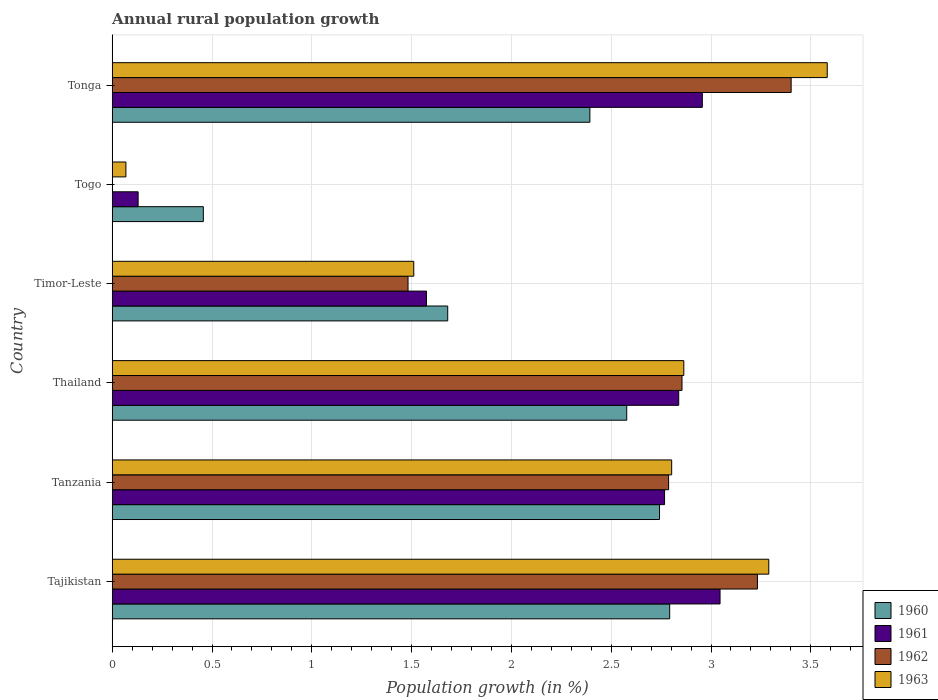How many bars are there on the 1st tick from the top?
Offer a terse response. 4. What is the label of the 5th group of bars from the top?
Offer a very short reply. Tanzania. In how many cases, is the number of bars for a given country not equal to the number of legend labels?
Keep it short and to the point. 1. What is the percentage of rural population growth in 1962 in Thailand?
Your answer should be compact. 2.85. Across all countries, what is the maximum percentage of rural population growth in 1963?
Ensure brevity in your answer.  3.58. Across all countries, what is the minimum percentage of rural population growth in 1962?
Ensure brevity in your answer.  0. In which country was the percentage of rural population growth in 1963 maximum?
Your response must be concise. Tonga. What is the total percentage of rural population growth in 1960 in the graph?
Ensure brevity in your answer.  12.64. What is the difference between the percentage of rural population growth in 1963 in Timor-Leste and that in Tonga?
Keep it short and to the point. -2.07. What is the difference between the percentage of rural population growth in 1960 in Timor-Leste and the percentage of rural population growth in 1962 in Thailand?
Your response must be concise. -1.17. What is the average percentage of rural population growth in 1960 per country?
Provide a succinct answer. 2.11. What is the difference between the percentage of rural population growth in 1962 and percentage of rural population growth in 1961 in Tonga?
Your answer should be very brief. 0.44. In how many countries, is the percentage of rural population growth in 1960 greater than 2.2 %?
Your answer should be compact. 4. What is the ratio of the percentage of rural population growth in 1963 in Tanzania to that in Togo?
Offer a very short reply. 40.89. Is the percentage of rural population growth in 1960 in Tajikistan less than that in Timor-Leste?
Your response must be concise. No. What is the difference between the highest and the second highest percentage of rural population growth in 1961?
Make the answer very short. 0.09. What is the difference between the highest and the lowest percentage of rural population growth in 1960?
Keep it short and to the point. 2.34. Is the sum of the percentage of rural population growth in 1960 in Timor-Leste and Tonga greater than the maximum percentage of rural population growth in 1961 across all countries?
Provide a succinct answer. Yes. Is it the case that in every country, the sum of the percentage of rural population growth in 1962 and percentage of rural population growth in 1960 is greater than the sum of percentage of rural population growth in 1961 and percentage of rural population growth in 1963?
Provide a succinct answer. No. Is it the case that in every country, the sum of the percentage of rural population growth in 1962 and percentage of rural population growth in 1961 is greater than the percentage of rural population growth in 1963?
Give a very brief answer. Yes. How many bars are there?
Give a very brief answer. 23. Are all the bars in the graph horizontal?
Provide a succinct answer. Yes. How many countries are there in the graph?
Your answer should be very brief. 6. Are the values on the major ticks of X-axis written in scientific E-notation?
Keep it short and to the point. No. Does the graph contain grids?
Keep it short and to the point. Yes. Where does the legend appear in the graph?
Offer a terse response. Bottom right. How are the legend labels stacked?
Your answer should be compact. Vertical. What is the title of the graph?
Make the answer very short. Annual rural population growth. Does "1979" appear as one of the legend labels in the graph?
Ensure brevity in your answer.  No. What is the label or title of the X-axis?
Your response must be concise. Population growth (in %). What is the label or title of the Y-axis?
Offer a very short reply. Country. What is the Population growth (in %) in 1960 in Tajikistan?
Offer a very short reply. 2.79. What is the Population growth (in %) of 1961 in Tajikistan?
Give a very brief answer. 3.05. What is the Population growth (in %) of 1962 in Tajikistan?
Your answer should be very brief. 3.23. What is the Population growth (in %) of 1963 in Tajikistan?
Ensure brevity in your answer.  3.29. What is the Population growth (in %) in 1960 in Tanzania?
Provide a short and direct response. 2.74. What is the Population growth (in %) in 1961 in Tanzania?
Give a very brief answer. 2.77. What is the Population growth (in %) in 1962 in Tanzania?
Offer a terse response. 2.79. What is the Population growth (in %) in 1963 in Tanzania?
Offer a very short reply. 2.8. What is the Population growth (in %) in 1960 in Thailand?
Your answer should be very brief. 2.58. What is the Population growth (in %) of 1961 in Thailand?
Offer a terse response. 2.84. What is the Population growth (in %) of 1962 in Thailand?
Your answer should be very brief. 2.85. What is the Population growth (in %) of 1963 in Thailand?
Give a very brief answer. 2.86. What is the Population growth (in %) in 1960 in Timor-Leste?
Provide a succinct answer. 1.68. What is the Population growth (in %) in 1961 in Timor-Leste?
Ensure brevity in your answer.  1.57. What is the Population growth (in %) of 1962 in Timor-Leste?
Provide a short and direct response. 1.48. What is the Population growth (in %) of 1963 in Timor-Leste?
Offer a very short reply. 1.51. What is the Population growth (in %) of 1960 in Togo?
Provide a short and direct response. 0.46. What is the Population growth (in %) of 1961 in Togo?
Your response must be concise. 0.13. What is the Population growth (in %) in 1962 in Togo?
Your answer should be very brief. 0. What is the Population growth (in %) in 1963 in Togo?
Give a very brief answer. 0.07. What is the Population growth (in %) of 1960 in Tonga?
Keep it short and to the point. 2.39. What is the Population growth (in %) in 1961 in Tonga?
Your answer should be very brief. 2.96. What is the Population growth (in %) of 1962 in Tonga?
Your answer should be compact. 3.4. What is the Population growth (in %) of 1963 in Tonga?
Provide a succinct answer. 3.58. Across all countries, what is the maximum Population growth (in %) in 1960?
Provide a succinct answer. 2.79. Across all countries, what is the maximum Population growth (in %) of 1961?
Make the answer very short. 3.05. Across all countries, what is the maximum Population growth (in %) in 1962?
Offer a terse response. 3.4. Across all countries, what is the maximum Population growth (in %) of 1963?
Make the answer very short. 3.58. Across all countries, what is the minimum Population growth (in %) of 1960?
Make the answer very short. 0.46. Across all countries, what is the minimum Population growth (in %) of 1961?
Make the answer very short. 0.13. Across all countries, what is the minimum Population growth (in %) of 1963?
Give a very brief answer. 0.07. What is the total Population growth (in %) of 1960 in the graph?
Make the answer very short. 12.64. What is the total Population growth (in %) in 1961 in the graph?
Offer a very short reply. 13.31. What is the total Population growth (in %) of 1962 in the graph?
Offer a terse response. 13.76. What is the total Population growth (in %) of 1963 in the graph?
Your answer should be compact. 14.12. What is the difference between the Population growth (in %) of 1960 in Tajikistan and that in Tanzania?
Your answer should be very brief. 0.05. What is the difference between the Population growth (in %) of 1961 in Tajikistan and that in Tanzania?
Your answer should be very brief. 0.28. What is the difference between the Population growth (in %) of 1962 in Tajikistan and that in Tanzania?
Offer a very short reply. 0.45. What is the difference between the Population growth (in %) of 1963 in Tajikistan and that in Tanzania?
Give a very brief answer. 0.49. What is the difference between the Population growth (in %) of 1960 in Tajikistan and that in Thailand?
Offer a terse response. 0.22. What is the difference between the Population growth (in %) in 1961 in Tajikistan and that in Thailand?
Your answer should be very brief. 0.21. What is the difference between the Population growth (in %) of 1962 in Tajikistan and that in Thailand?
Your response must be concise. 0.38. What is the difference between the Population growth (in %) of 1963 in Tajikistan and that in Thailand?
Ensure brevity in your answer.  0.43. What is the difference between the Population growth (in %) in 1960 in Tajikistan and that in Timor-Leste?
Make the answer very short. 1.11. What is the difference between the Population growth (in %) of 1961 in Tajikistan and that in Timor-Leste?
Offer a terse response. 1.47. What is the difference between the Population growth (in %) of 1962 in Tajikistan and that in Timor-Leste?
Your answer should be very brief. 1.75. What is the difference between the Population growth (in %) in 1963 in Tajikistan and that in Timor-Leste?
Offer a very short reply. 1.78. What is the difference between the Population growth (in %) in 1960 in Tajikistan and that in Togo?
Keep it short and to the point. 2.34. What is the difference between the Population growth (in %) of 1961 in Tajikistan and that in Togo?
Provide a succinct answer. 2.92. What is the difference between the Population growth (in %) of 1963 in Tajikistan and that in Togo?
Ensure brevity in your answer.  3.22. What is the difference between the Population growth (in %) in 1960 in Tajikistan and that in Tonga?
Make the answer very short. 0.4. What is the difference between the Population growth (in %) of 1961 in Tajikistan and that in Tonga?
Provide a short and direct response. 0.09. What is the difference between the Population growth (in %) of 1962 in Tajikistan and that in Tonga?
Your response must be concise. -0.17. What is the difference between the Population growth (in %) in 1963 in Tajikistan and that in Tonga?
Offer a terse response. -0.29. What is the difference between the Population growth (in %) of 1960 in Tanzania and that in Thailand?
Your answer should be very brief. 0.16. What is the difference between the Population growth (in %) of 1961 in Tanzania and that in Thailand?
Make the answer very short. -0.07. What is the difference between the Population growth (in %) of 1962 in Tanzania and that in Thailand?
Your answer should be very brief. -0.07. What is the difference between the Population growth (in %) of 1963 in Tanzania and that in Thailand?
Your answer should be very brief. -0.06. What is the difference between the Population growth (in %) of 1960 in Tanzania and that in Timor-Leste?
Ensure brevity in your answer.  1.06. What is the difference between the Population growth (in %) of 1961 in Tanzania and that in Timor-Leste?
Provide a short and direct response. 1.19. What is the difference between the Population growth (in %) of 1962 in Tanzania and that in Timor-Leste?
Your answer should be very brief. 1.31. What is the difference between the Population growth (in %) of 1963 in Tanzania and that in Timor-Leste?
Offer a very short reply. 1.29. What is the difference between the Population growth (in %) of 1960 in Tanzania and that in Togo?
Make the answer very short. 2.29. What is the difference between the Population growth (in %) of 1961 in Tanzania and that in Togo?
Offer a terse response. 2.64. What is the difference between the Population growth (in %) in 1963 in Tanzania and that in Togo?
Offer a terse response. 2.73. What is the difference between the Population growth (in %) of 1960 in Tanzania and that in Tonga?
Your response must be concise. 0.35. What is the difference between the Population growth (in %) of 1961 in Tanzania and that in Tonga?
Provide a succinct answer. -0.19. What is the difference between the Population growth (in %) in 1962 in Tanzania and that in Tonga?
Your response must be concise. -0.61. What is the difference between the Population growth (in %) in 1963 in Tanzania and that in Tonga?
Your response must be concise. -0.78. What is the difference between the Population growth (in %) in 1960 in Thailand and that in Timor-Leste?
Provide a succinct answer. 0.9. What is the difference between the Population growth (in %) of 1961 in Thailand and that in Timor-Leste?
Ensure brevity in your answer.  1.26. What is the difference between the Population growth (in %) in 1962 in Thailand and that in Timor-Leste?
Make the answer very short. 1.37. What is the difference between the Population growth (in %) of 1963 in Thailand and that in Timor-Leste?
Ensure brevity in your answer.  1.35. What is the difference between the Population growth (in %) in 1960 in Thailand and that in Togo?
Make the answer very short. 2.12. What is the difference between the Population growth (in %) in 1961 in Thailand and that in Togo?
Give a very brief answer. 2.71. What is the difference between the Population growth (in %) of 1963 in Thailand and that in Togo?
Provide a short and direct response. 2.8. What is the difference between the Population growth (in %) of 1960 in Thailand and that in Tonga?
Make the answer very short. 0.18. What is the difference between the Population growth (in %) in 1961 in Thailand and that in Tonga?
Provide a succinct answer. -0.12. What is the difference between the Population growth (in %) in 1962 in Thailand and that in Tonga?
Make the answer very short. -0.55. What is the difference between the Population growth (in %) of 1963 in Thailand and that in Tonga?
Give a very brief answer. -0.72. What is the difference between the Population growth (in %) of 1960 in Timor-Leste and that in Togo?
Provide a succinct answer. 1.22. What is the difference between the Population growth (in %) in 1961 in Timor-Leste and that in Togo?
Your answer should be very brief. 1.44. What is the difference between the Population growth (in %) in 1963 in Timor-Leste and that in Togo?
Ensure brevity in your answer.  1.44. What is the difference between the Population growth (in %) in 1960 in Timor-Leste and that in Tonga?
Keep it short and to the point. -0.71. What is the difference between the Population growth (in %) of 1961 in Timor-Leste and that in Tonga?
Your response must be concise. -1.38. What is the difference between the Population growth (in %) in 1962 in Timor-Leste and that in Tonga?
Offer a terse response. -1.92. What is the difference between the Population growth (in %) of 1963 in Timor-Leste and that in Tonga?
Make the answer very short. -2.07. What is the difference between the Population growth (in %) in 1960 in Togo and that in Tonga?
Give a very brief answer. -1.94. What is the difference between the Population growth (in %) in 1961 in Togo and that in Tonga?
Your answer should be very brief. -2.83. What is the difference between the Population growth (in %) of 1963 in Togo and that in Tonga?
Your answer should be very brief. -3.51. What is the difference between the Population growth (in %) in 1960 in Tajikistan and the Population growth (in %) in 1961 in Tanzania?
Keep it short and to the point. 0.03. What is the difference between the Population growth (in %) in 1960 in Tajikistan and the Population growth (in %) in 1962 in Tanzania?
Your response must be concise. 0.01. What is the difference between the Population growth (in %) in 1960 in Tajikistan and the Population growth (in %) in 1963 in Tanzania?
Give a very brief answer. -0.01. What is the difference between the Population growth (in %) of 1961 in Tajikistan and the Population growth (in %) of 1962 in Tanzania?
Give a very brief answer. 0.26. What is the difference between the Population growth (in %) of 1961 in Tajikistan and the Population growth (in %) of 1963 in Tanzania?
Give a very brief answer. 0.24. What is the difference between the Population growth (in %) in 1962 in Tajikistan and the Population growth (in %) in 1963 in Tanzania?
Provide a succinct answer. 0.43. What is the difference between the Population growth (in %) in 1960 in Tajikistan and the Population growth (in %) in 1961 in Thailand?
Provide a succinct answer. -0.05. What is the difference between the Population growth (in %) of 1960 in Tajikistan and the Population growth (in %) of 1962 in Thailand?
Offer a terse response. -0.06. What is the difference between the Population growth (in %) of 1960 in Tajikistan and the Population growth (in %) of 1963 in Thailand?
Your answer should be very brief. -0.07. What is the difference between the Population growth (in %) of 1961 in Tajikistan and the Population growth (in %) of 1962 in Thailand?
Offer a very short reply. 0.19. What is the difference between the Population growth (in %) of 1961 in Tajikistan and the Population growth (in %) of 1963 in Thailand?
Give a very brief answer. 0.18. What is the difference between the Population growth (in %) of 1962 in Tajikistan and the Population growth (in %) of 1963 in Thailand?
Your answer should be very brief. 0.37. What is the difference between the Population growth (in %) in 1960 in Tajikistan and the Population growth (in %) in 1961 in Timor-Leste?
Your answer should be compact. 1.22. What is the difference between the Population growth (in %) of 1960 in Tajikistan and the Population growth (in %) of 1962 in Timor-Leste?
Offer a very short reply. 1.31. What is the difference between the Population growth (in %) in 1960 in Tajikistan and the Population growth (in %) in 1963 in Timor-Leste?
Give a very brief answer. 1.28. What is the difference between the Population growth (in %) of 1961 in Tajikistan and the Population growth (in %) of 1962 in Timor-Leste?
Offer a terse response. 1.56. What is the difference between the Population growth (in %) of 1961 in Tajikistan and the Population growth (in %) of 1963 in Timor-Leste?
Ensure brevity in your answer.  1.53. What is the difference between the Population growth (in %) in 1962 in Tajikistan and the Population growth (in %) in 1963 in Timor-Leste?
Provide a short and direct response. 1.72. What is the difference between the Population growth (in %) in 1960 in Tajikistan and the Population growth (in %) in 1961 in Togo?
Your response must be concise. 2.66. What is the difference between the Population growth (in %) in 1960 in Tajikistan and the Population growth (in %) in 1963 in Togo?
Give a very brief answer. 2.72. What is the difference between the Population growth (in %) in 1961 in Tajikistan and the Population growth (in %) in 1963 in Togo?
Your answer should be compact. 2.98. What is the difference between the Population growth (in %) in 1962 in Tajikistan and the Population growth (in %) in 1963 in Togo?
Your answer should be very brief. 3.16. What is the difference between the Population growth (in %) in 1960 in Tajikistan and the Population growth (in %) in 1961 in Tonga?
Provide a succinct answer. -0.16. What is the difference between the Population growth (in %) of 1960 in Tajikistan and the Population growth (in %) of 1962 in Tonga?
Offer a very short reply. -0.61. What is the difference between the Population growth (in %) of 1960 in Tajikistan and the Population growth (in %) of 1963 in Tonga?
Ensure brevity in your answer.  -0.79. What is the difference between the Population growth (in %) of 1961 in Tajikistan and the Population growth (in %) of 1962 in Tonga?
Provide a short and direct response. -0.36. What is the difference between the Population growth (in %) of 1961 in Tajikistan and the Population growth (in %) of 1963 in Tonga?
Keep it short and to the point. -0.54. What is the difference between the Population growth (in %) of 1962 in Tajikistan and the Population growth (in %) of 1963 in Tonga?
Provide a succinct answer. -0.35. What is the difference between the Population growth (in %) in 1960 in Tanzania and the Population growth (in %) in 1961 in Thailand?
Offer a terse response. -0.1. What is the difference between the Population growth (in %) of 1960 in Tanzania and the Population growth (in %) of 1962 in Thailand?
Give a very brief answer. -0.11. What is the difference between the Population growth (in %) of 1960 in Tanzania and the Population growth (in %) of 1963 in Thailand?
Offer a very short reply. -0.12. What is the difference between the Population growth (in %) in 1961 in Tanzania and the Population growth (in %) in 1962 in Thailand?
Keep it short and to the point. -0.09. What is the difference between the Population growth (in %) in 1961 in Tanzania and the Population growth (in %) in 1963 in Thailand?
Your answer should be very brief. -0.1. What is the difference between the Population growth (in %) of 1962 in Tanzania and the Population growth (in %) of 1963 in Thailand?
Make the answer very short. -0.08. What is the difference between the Population growth (in %) in 1960 in Tanzania and the Population growth (in %) in 1961 in Timor-Leste?
Ensure brevity in your answer.  1.17. What is the difference between the Population growth (in %) in 1960 in Tanzania and the Population growth (in %) in 1962 in Timor-Leste?
Ensure brevity in your answer.  1.26. What is the difference between the Population growth (in %) of 1960 in Tanzania and the Population growth (in %) of 1963 in Timor-Leste?
Offer a terse response. 1.23. What is the difference between the Population growth (in %) of 1961 in Tanzania and the Population growth (in %) of 1962 in Timor-Leste?
Your answer should be compact. 1.29. What is the difference between the Population growth (in %) of 1961 in Tanzania and the Population growth (in %) of 1963 in Timor-Leste?
Ensure brevity in your answer.  1.26. What is the difference between the Population growth (in %) in 1962 in Tanzania and the Population growth (in %) in 1963 in Timor-Leste?
Your answer should be compact. 1.28. What is the difference between the Population growth (in %) in 1960 in Tanzania and the Population growth (in %) in 1961 in Togo?
Your response must be concise. 2.61. What is the difference between the Population growth (in %) in 1960 in Tanzania and the Population growth (in %) in 1963 in Togo?
Ensure brevity in your answer.  2.67. What is the difference between the Population growth (in %) in 1961 in Tanzania and the Population growth (in %) in 1963 in Togo?
Your answer should be compact. 2.7. What is the difference between the Population growth (in %) in 1962 in Tanzania and the Population growth (in %) in 1963 in Togo?
Your answer should be compact. 2.72. What is the difference between the Population growth (in %) in 1960 in Tanzania and the Population growth (in %) in 1961 in Tonga?
Your response must be concise. -0.21. What is the difference between the Population growth (in %) in 1960 in Tanzania and the Population growth (in %) in 1962 in Tonga?
Your answer should be very brief. -0.66. What is the difference between the Population growth (in %) in 1960 in Tanzania and the Population growth (in %) in 1963 in Tonga?
Ensure brevity in your answer.  -0.84. What is the difference between the Population growth (in %) of 1961 in Tanzania and the Population growth (in %) of 1962 in Tonga?
Offer a very short reply. -0.63. What is the difference between the Population growth (in %) of 1961 in Tanzania and the Population growth (in %) of 1963 in Tonga?
Ensure brevity in your answer.  -0.81. What is the difference between the Population growth (in %) in 1962 in Tanzania and the Population growth (in %) in 1963 in Tonga?
Your answer should be very brief. -0.79. What is the difference between the Population growth (in %) in 1960 in Thailand and the Population growth (in %) in 1962 in Timor-Leste?
Offer a very short reply. 1.1. What is the difference between the Population growth (in %) in 1960 in Thailand and the Population growth (in %) in 1963 in Timor-Leste?
Keep it short and to the point. 1.07. What is the difference between the Population growth (in %) in 1961 in Thailand and the Population growth (in %) in 1962 in Timor-Leste?
Provide a short and direct response. 1.36. What is the difference between the Population growth (in %) in 1961 in Thailand and the Population growth (in %) in 1963 in Timor-Leste?
Provide a short and direct response. 1.33. What is the difference between the Population growth (in %) of 1962 in Thailand and the Population growth (in %) of 1963 in Timor-Leste?
Ensure brevity in your answer.  1.34. What is the difference between the Population growth (in %) in 1960 in Thailand and the Population growth (in %) in 1961 in Togo?
Offer a terse response. 2.45. What is the difference between the Population growth (in %) in 1960 in Thailand and the Population growth (in %) in 1963 in Togo?
Ensure brevity in your answer.  2.51. What is the difference between the Population growth (in %) in 1961 in Thailand and the Population growth (in %) in 1963 in Togo?
Keep it short and to the point. 2.77. What is the difference between the Population growth (in %) in 1962 in Thailand and the Population growth (in %) in 1963 in Togo?
Make the answer very short. 2.79. What is the difference between the Population growth (in %) in 1960 in Thailand and the Population growth (in %) in 1961 in Tonga?
Your answer should be compact. -0.38. What is the difference between the Population growth (in %) of 1960 in Thailand and the Population growth (in %) of 1962 in Tonga?
Provide a succinct answer. -0.82. What is the difference between the Population growth (in %) in 1960 in Thailand and the Population growth (in %) in 1963 in Tonga?
Give a very brief answer. -1. What is the difference between the Population growth (in %) in 1961 in Thailand and the Population growth (in %) in 1962 in Tonga?
Keep it short and to the point. -0.56. What is the difference between the Population growth (in %) of 1961 in Thailand and the Population growth (in %) of 1963 in Tonga?
Offer a very short reply. -0.74. What is the difference between the Population growth (in %) of 1962 in Thailand and the Population growth (in %) of 1963 in Tonga?
Offer a terse response. -0.73. What is the difference between the Population growth (in %) in 1960 in Timor-Leste and the Population growth (in %) in 1961 in Togo?
Ensure brevity in your answer.  1.55. What is the difference between the Population growth (in %) in 1960 in Timor-Leste and the Population growth (in %) in 1963 in Togo?
Your answer should be very brief. 1.61. What is the difference between the Population growth (in %) of 1961 in Timor-Leste and the Population growth (in %) of 1963 in Togo?
Offer a terse response. 1.51. What is the difference between the Population growth (in %) of 1962 in Timor-Leste and the Population growth (in %) of 1963 in Togo?
Give a very brief answer. 1.41. What is the difference between the Population growth (in %) in 1960 in Timor-Leste and the Population growth (in %) in 1961 in Tonga?
Your answer should be compact. -1.28. What is the difference between the Population growth (in %) in 1960 in Timor-Leste and the Population growth (in %) in 1962 in Tonga?
Ensure brevity in your answer.  -1.72. What is the difference between the Population growth (in %) in 1960 in Timor-Leste and the Population growth (in %) in 1963 in Tonga?
Your answer should be compact. -1.9. What is the difference between the Population growth (in %) of 1961 in Timor-Leste and the Population growth (in %) of 1962 in Tonga?
Keep it short and to the point. -1.83. What is the difference between the Population growth (in %) of 1961 in Timor-Leste and the Population growth (in %) of 1963 in Tonga?
Your answer should be very brief. -2.01. What is the difference between the Population growth (in %) in 1962 in Timor-Leste and the Population growth (in %) in 1963 in Tonga?
Offer a very short reply. -2.1. What is the difference between the Population growth (in %) in 1960 in Togo and the Population growth (in %) in 1961 in Tonga?
Make the answer very short. -2.5. What is the difference between the Population growth (in %) of 1960 in Togo and the Population growth (in %) of 1962 in Tonga?
Offer a very short reply. -2.94. What is the difference between the Population growth (in %) in 1960 in Togo and the Population growth (in %) in 1963 in Tonga?
Your response must be concise. -3.13. What is the difference between the Population growth (in %) of 1961 in Togo and the Population growth (in %) of 1962 in Tonga?
Your answer should be compact. -3.27. What is the difference between the Population growth (in %) in 1961 in Togo and the Population growth (in %) in 1963 in Tonga?
Keep it short and to the point. -3.45. What is the average Population growth (in %) of 1960 per country?
Your response must be concise. 2.11. What is the average Population growth (in %) in 1961 per country?
Ensure brevity in your answer.  2.22. What is the average Population growth (in %) of 1962 per country?
Provide a succinct answer. 2.29. What is the average Population growth (in %) of 1963 per country?
Provide a succinct answer. 2.35. What is the difference between the Population growth (in %) in 1960 and Population growth (in %) in 1961 in Tajikistan?
Keep it short and to the point. -0.25. What is the difference between the Population growth (in %) in 1960 and Population growth (in %) in 1962 in Tajikistan?
Provide a short and direct response. -0.44. What is the difference between the Population growth (in %) in 1960 and Population growth (in %) in 1963 in Tajikistan?
Keep it short and to the point. -0.5. What is the difference between the Population growth (in %) of 1961 and Population growth (in %) of 1962 in Tajikistan?
Give a very brief answer. -0.19. What is the difference between the Population growth (in %) in 1961 and Population growth (in %) in 1963 in Tajikistan?
Offer a very short reply. -0.24. What is the difference between the Population growth (in %) of 1962 and Population growth (in %) of 1963 in Tajikistan?
Provide a short and direct response. -0.06. What is the difference between the Population growth (in %) in 1960 and Population growth (in %) in 1961 in Tanzania?
Keep it short and to the point. -0.03. What is the difference between the Population growth (in %) of 1960 and Population growth (in %) of 1962 in Tanzania?
Your response must be concise. -0.05. What is the difference between the Population growth (in %) in 1960 and Population growth (in %) in 1963 in Tanzania?
Ensure brevity in your answer.  -0.06. What is the difference between the Population growth (in %) of 1961 and Population growth (in %) of 1962 in Tanzania?
Provide a short and direct response. -0.02. What is the difference between the Population growth (in %) in 1961 and Population growth (in %) in 1963 in Tanzania?
Offer a terse response. -0.04. What is the difference between the Population growth (in %) of 1962 and Population growth (in %) of 1963 in Tanzania?
Your answer should be compact. -0.02. What is the difference between the Population growth (in %) in 1960 and Population growth (in %) in 1961 in Thailand?
Ensure brevity in your answer.  -0.26. What is the difference between the Population growth (in %) in 1960 and Population growth (in %) in 1962 in Thailand?
Make the answer very short. -0.28. What is the difference between the Population growth (in %) of 1960 and Population growth (in %) of 1963 in Thailand?
Offer a terse response. -0.29. What is the difference between the Population growth (in %) in 1961 and Population growth (in %) in 1962 in Thailand?
Your response must be concise. -0.02. What is the difference between the Population growth (in %) of 1961 and Population growth (in %) of 1963 in Thailand?
Provide a succinct answer. -0.03. What is the difference between the Population growth (in %) in 1962 and Population growth (in %) in 1963 in Thailand?
Ensure brevity in your answer.  -0.01. What is the difference between the Population growth (in %) of 1960 and Population growth (in %) of 1961 in Timor-Leste?
Ensure brevity in your answer.  0.11. What is the difference between the Population growth (in %) of 1960 and Population growth (in %) of 1962 in Timor-Leste?
Provide a short and direct response. 0.2. What is the difference between the Population growth (in %) of 1960 and Population growth (in %) of 1963 in Timor-Leste?
Keep it short and to the point. 0.17. What is the difference between the Population growth (in %) of 1961 and Population growth (in %) of 1962 in Timor-Leste?
Offer a terse response. 0.09. What is the difference between the Population growth (in %) of 1961 and Population growth (in %) of 1963 in Timor-Leste?
Make the answer very short. 0.06. What is the difference between the Population growth (in %) in 1962 and Population growth (in %) in 1963 in Timor-Leste?
Make the answer very short. -0.03. What is the difference between the Population growth (in %) in 1960 and Population growth (in %) in 1961 in Togo?
Give a very brief answer. 0.33. What is the difference between the Population growth (in %) in 1960 and Population growth (in %) in 1963 in Togo?
Keep it short and to the point. 0.39. What is the difference between the Population growth (in %) in 1961 and Population growth (in %) in 1963 in Togo?
Provide a succinct answer. 0.06. What is the difference between the Population growth (in %) in 1960 and Population growth (in %) in 1961 in Tonga?
Provide a succinct answer. -0.56. What is the difference between the Population growth (in %) of 1960 and Population growth (in %) of 1962 in Tonga?
Make the answer very short. -1.01. What is the difference between the Population growth (in %) in 1960 and Population growth (in %) in 1963 in Tonga?
Your response must be concise. -1.19. What is the difference between the Population growth (in %) of 1961 and Population growth (in %) of 1962 in Tonga?
Your response must be concise. -0.44. What is the difference between the Population growth (in %) in 1961 and Population growth (in %) in 1963 in Tonga?
Your response must be concise. -0.63. What is the difference between the Population growth (in %) of 1962 and Population growth (in %) of 1963 in Tonga?
Keep it short and to the point. -0.18. What is the ratio of the Population growth (in %) in 1960 in Tajikistan to that in Tanzania?
Offer a very short reply. 1.02. What is the ratio of the Population growth (in %) in 1961 in Tajikistan to that in Tanzania?
Your response must be concise. 1.1. What is the ratio of the Population growth (in %) of 1962 in Tajikistan to that in Tanzania?
Give a very brief answer. 1.16. What is the ratio of the Population growth (in %) in 1963 in Tajikistan to that in Tanzania?
Offer a very short reply. 1.17. What is the ratio of the Population growth (in %) in 1960 in Tajikistan to that in Thailand?
Offer a very short reply. 1.08. What is the ratio of the Population growth (in %) of 1961 in Tajikistan to that in Thailand?
Your answer should be very brief. 1.07. What is the ratio of the Population growth (in %) of 1962 in Tajikistan to that in Thailand?
Make the answer very short. 1.13. What is the ratio of the Population growth (in %) of 1963 in Tajikistan to that in Thailand?
Offer a terse response. 1.15. What is the ratio of the Population growth (in %) in 1960 in Tajikistan to that in Timor-Leste?
Give a very brief answer. 1.66. What is the ratio of the Population growth (in %) in 1961 in Tajikistan to that in Timor-Leste?
Offer a terse response. 1.93. What is the ratio of the Population growth (in %) of 1962 in Tajikistan to that in Timor-Leste?
Provide a short and direct response. 2.18. What is the ratio of the Population growth (in %) of 1963 in Tajikistan to that in Timor-Leste?
Make the answer very short. 2.18. What is the ratio of the Population growth (in %) of 1960 in Tajikistan to that in Togo?
Give a very brief answer. 6.12. What is the ratio of the Population growth (in %) of 1961 in Tajikistan to that in Togo?
Provide a succinct answer. 23.47. What is the ratio of the Population growth (in %) in 1963 in Tajikistan to that in Togo?
Your response must be concise. 47.98. What is the ratio of the Population growth (in %) of 1960 in Tajikistan to that in Tonga?
Ensure brevity in your answer.  1.17. What is the ratio of the Population growth (in %) of 1962 in Tajikistan to that in Tonga?
Offer a terse response. 0.95. What is the ratio of the Population growth (in %) in 1963 in Tajikistan to that in Tonga?
Your answer should be very brief. 0.92. What is the ratio of the Population growth (in %) in 1960 in Tanzania to that in Thailand?
Your answer should be very brief. 1.06. What is the ratio of the Population growth (in %) in 1961 in Tanzania to that in Thailand?
Provide a succinct answer. 0.97. What is the ratio of the Population growth (in %) in 1962 in Tanzania to that in Thailand?
Give a very brief answer. 0.98. What is the ratio of the Population growth (in %) in 1963 in Tanzania to that in Thailand?
Ensure brevity in your answer.  0.98. What is the ratio of the Population growth (in %) of 1960 in Tanzania to that in Timor-Leste?
Offer a very short reply. 1.63. What is the ratio of the Population growth (in %) in 1961 in Tanzania to that in Timor-Leste?
Provide a succinct answer. 1.76. What is the ratio of the Population growth (in %) in 1962 in Tanzania to that in Timor-Leste?
Your response must be concise. 1.88. What is the ratio of the Population growth (in %) of 1963 in Tanzania to that in Timor-Leste?
Your response must be concise. 1.86. What is the ratio of the Population growth (in %) in 1960 in Tanzania to that in Togo?
Offer a terse response. 6.01. What is the ratio of the Population growth (in %) in 1961 in Tanzania to that in Togo?
Provide a succinct answer. 21.33. What is the ratio of the Population growth (in %) in 1963 in Tanzania to that in Togo?
Provide a short and direct response. 40.89. What is the ratio of the Population growth (in %) of 1960 in Tanzania to that in Tonga?
Ensure brevity in your answer.  1.15. What is the ratio of the Population growth (in %) in 1961 in Tanzania to that in Tonga?
Keep it short and to the point. 0.94. What is the ratio of the Population growth (in %) of 1962 in Tanzania to that in Tonga?
Provide a succinct answer. 0.82. What is the ratio of the Population growth (in %) of 1963 in Tanzania to that in Tonga?
Make the answer very short. 0.78. What is the ratio of the Population growth (in %) of 1960 in Thailand to that in Timor-Leste?
Offer a terse response. 1.53. What is the ratio of the Population growth (in %) in 1961 in Thailand to that in Timor-Leste?
Keep it short and to the point. 1.8. What is the ratio of the Population growth (in %) of 1962 in Thailand to that in Timor-Leste?
Give a very brief answer. 1.93. What is the ratio of the Population growth (in %) of 1963 in Thailand to that in Timor-Leste?
Your answer should be compact. 1.9. What is the ratio of the Population growth (in %) of 1960 in Thailand to that in Togo?
Provide a short and direct response. 5.65. What is the ratio of the Population growth (in %) in 1961 in Thailand to that in Togo?
Keep it short and to the point. 21.87. What is the ratio of the Population growth (in %) in 1963 in Thailand to that in Togo?
Your answer should be compact. 41.77. What is the ratio of the Population growth (in %) in 1960 in Thailand to that in Tonga?
Offer a very short reply. 1.08. What is the ratio of the Population growth (in %) of 1962 in Thailand to that in Tonga?
Give a very brief answer. 0.84. What is the ratio of the Population growth (in %) of 1963 in Thailand to that in Tonga?
Make the answer very short. 0.8. What is the ratio of the Population growth (in %) in 1960 in Timor-Leste to that in Togo?
Ensure brevity in your answer.  3.68. What is the ratio of the Population growth (in %) of 1961 in Timor-Leste to that in Togo?
Provide a succinct answer. 12.13. What is the ratio of the Population growth (in %) in 1963 in Timor-Leste to that in Togo?
Your answer should be very brief. 22.04. What is the ratio of the Population growth (in %) of 1960 in Timor-Leste to that in Tonga?
Provide a short and direct response. 0.7. What is the ratio of the Population growth (in %) of 1961 in Timor-Leste to that in Tonga?
Your response must be concise. 0.53. What is the ratio of the Population growth (in %) in 1962 in Timor-Leste to that in Tonga?
Offer a terse response. 0.44. What is the ratio of the Population growth (in %) in 1963 in Timor-Leste to that in Tonga?
Make the answer very short. 0.42. What is the ratio of the Population growth (in %) of 1960 in Togo to that in Tonga?
Provide a succinct answer. 0.19. What is the ratio of the Population growth (in %) of 1961 in Togo to that in Tonga?
Your response must be concise. 0.04. What is the ratio of the Population growth (in %) in 1963 in Togo to that in Tonga?
Your answer should be compact. 0.02. What is the difference between the highest and the second highest Population growth (in %) in 1960?
Provide a short and direct response. 0.05. What is the difference between the highest and the second highest Population growth (in %) in 1961?
Your answer should be compact. 0.09. What is the difference between the highest and the second highest Population growth (in %) in 1962?
Your answer should be very brief. 0.17. What is the difference between the highest and the second highest Population growth (in %) of 1963?
Your answer should be very brief. 0.29. What is the difference between the highest and the lowest Population growth (in %) in 1960?
Provide a short and direct response. 2.34. What is the difference between the highest and the lowest Population growth (in %) of 1961?
Make the answer very short. 2.92. What is the difference between the highest and the lowest Population growth (in %) of 1962?
Give a very brief answer. 3.4. What is the difference between the highest and the lowest Population growth (in %) of 1963?
Offer a terse response. 3.51. 